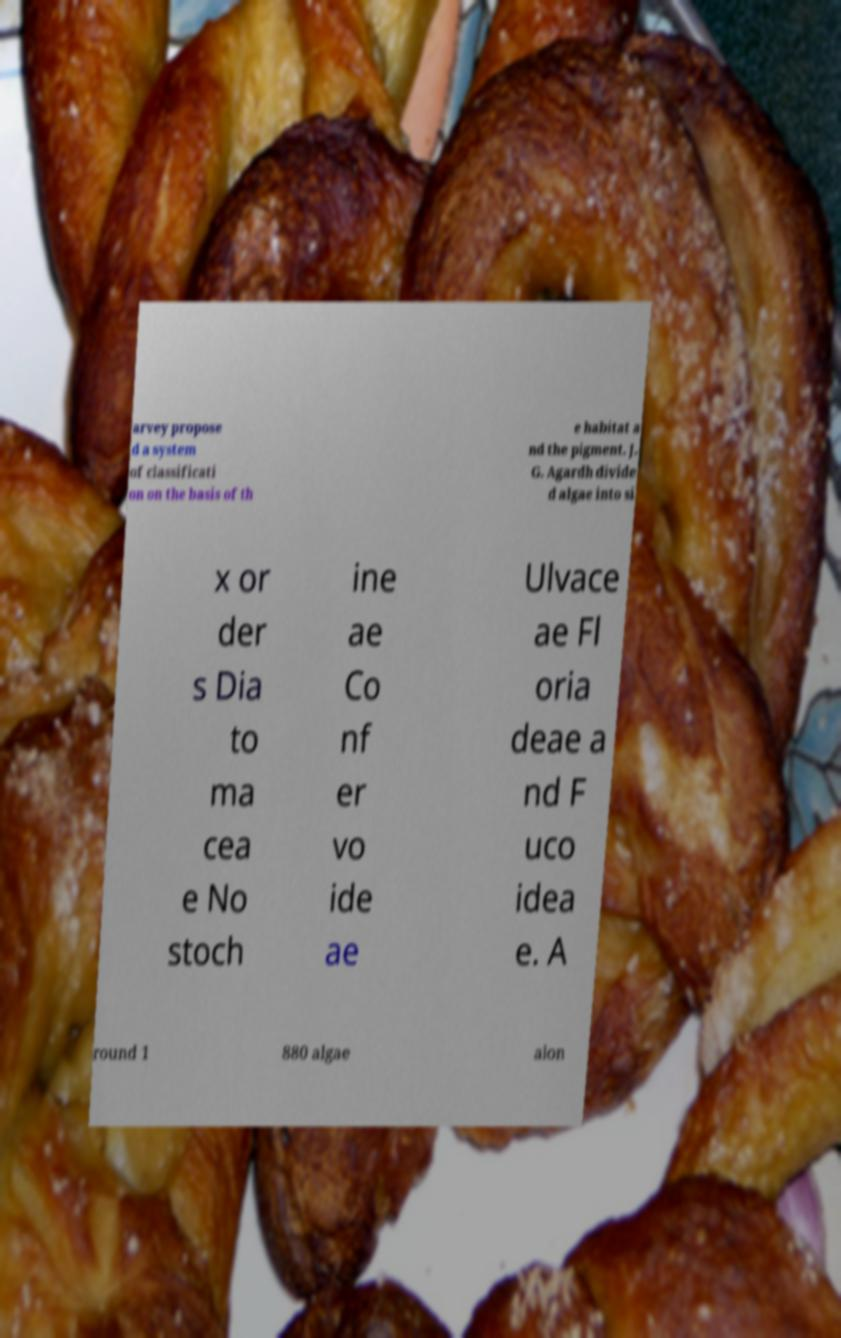Could you assist in decoding the text presented in this image and type it out clearly? arvey propose d a system of classificati on on the basis of th e habitat a nd the pigment. J. G. Agardh divide d algae into si x or der s Dia to ma cea e No stoch ine ae Co nf er vo ide ae Ulvace ae Fl oria deae a nd F uco idea e. A round 1 880 algae alon 